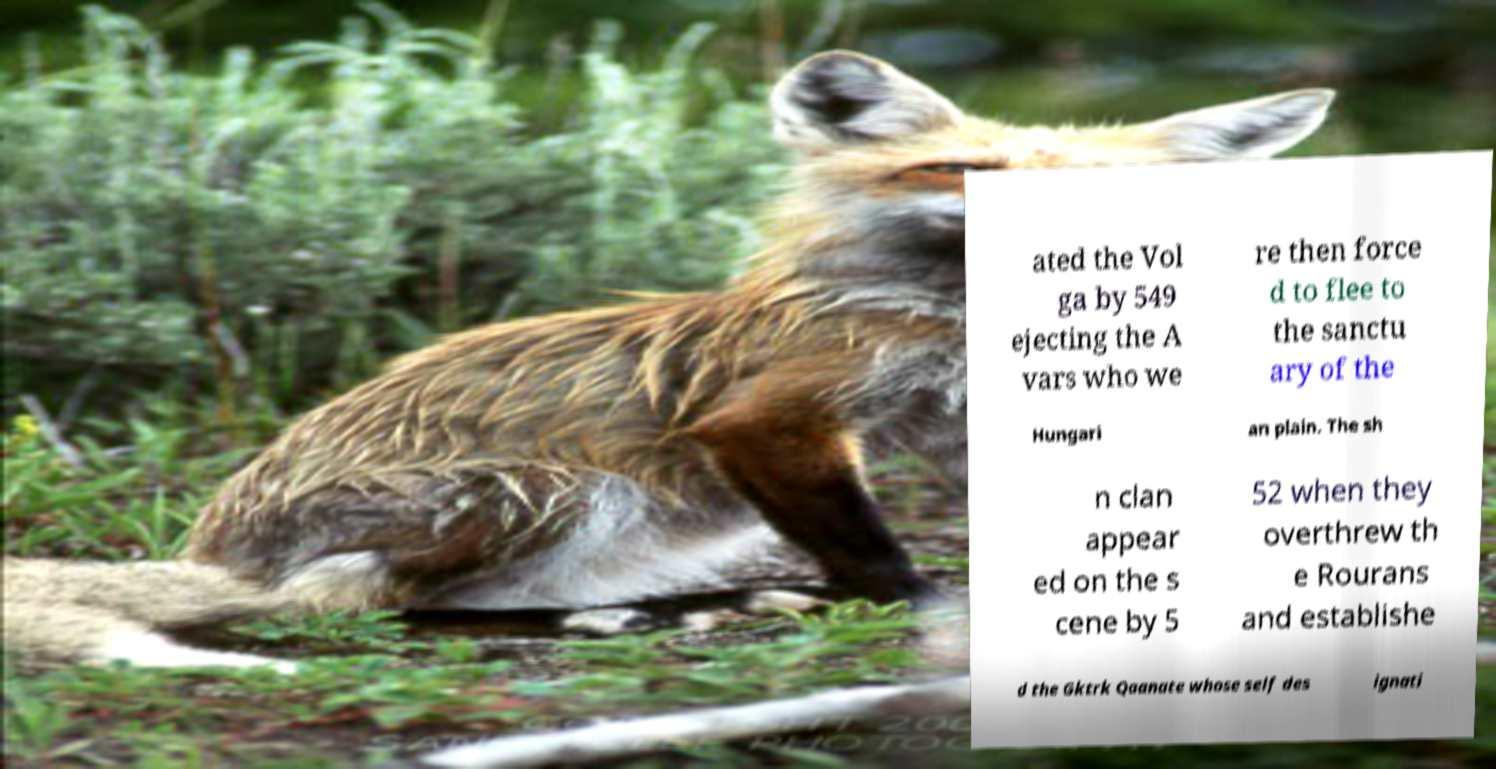There's text embedded in this image that I need extracted. Can you transcribe it verbatim? ated the Vol ga by 549 ejecting the A vars who we re then force d to flee to the sanctu ary of the Hungari an plain. The sh n clan appear ed on the s cene by 5 52 when they overthrew th e Rourans and establishe d the Gktrk Qaanate whose self des ignati 